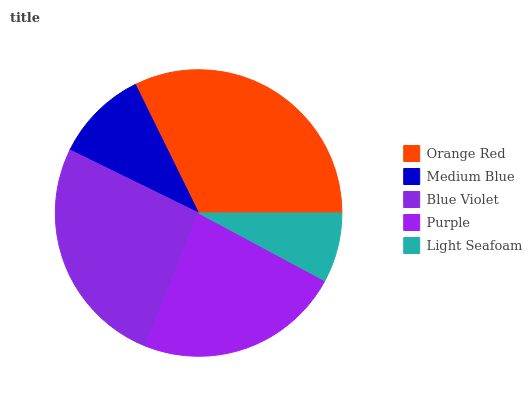Is Light Seafoam the minimum?
Answer yes or no. Yes. Is Orange Red the maximum?
Answer yes or no. Yes. Is Medium Blue the minimum?
Answer yes or no. No. Is Medium Blue the maximum?
Answer yes or no. No. Is Orange Red greater than Medium Blue?
Answer yes or no. Yes. Is Medium Blue less than Orange Red?
Answer yes or no. Yes. Is Medium Blue greater than Orange Red?
Answer yes or no. No. Is Orange Red less than Medium Blue?
Answer yes or no. No. Is Purple the high median?
Answer yes or no. Yes. Is Purple the low median?
Answer yes or no. Yes. Is Medium Blue the high median?
Answer yes or no. No. Is Light Seafoam the low median?
Answer yes or no. No. 